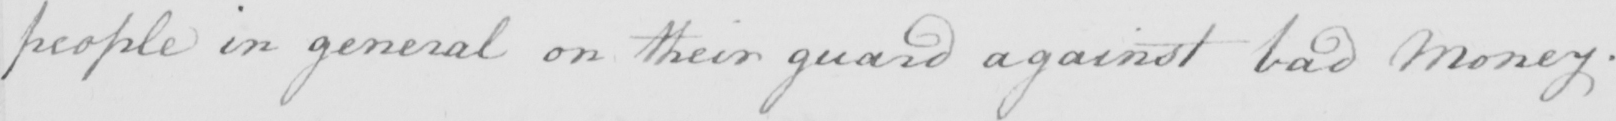Can you read and transcribe this handwriting? people in general on their guard against bad money . 